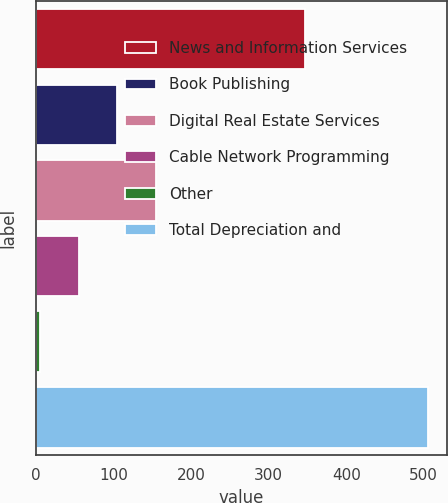Convert chart. <chart><loc_0><loc_0><loc_500><loc_500><bar_chart><fcel>News and Information Services<fcel>Book Publishing<fcel>Digital Real Estate Services<fcel>Cable Network Programming<fcel>Other<fcel>Total Depreciation and<nl><fcel>347<fcel>105<fcel>155<fcel>55<fcel>5<fcel>505<nl></chart> 